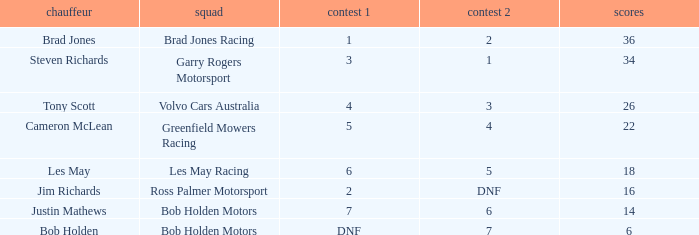Which driver for Greenfield Mowers Racing has fewer than 36 points? Cameron McLean. 